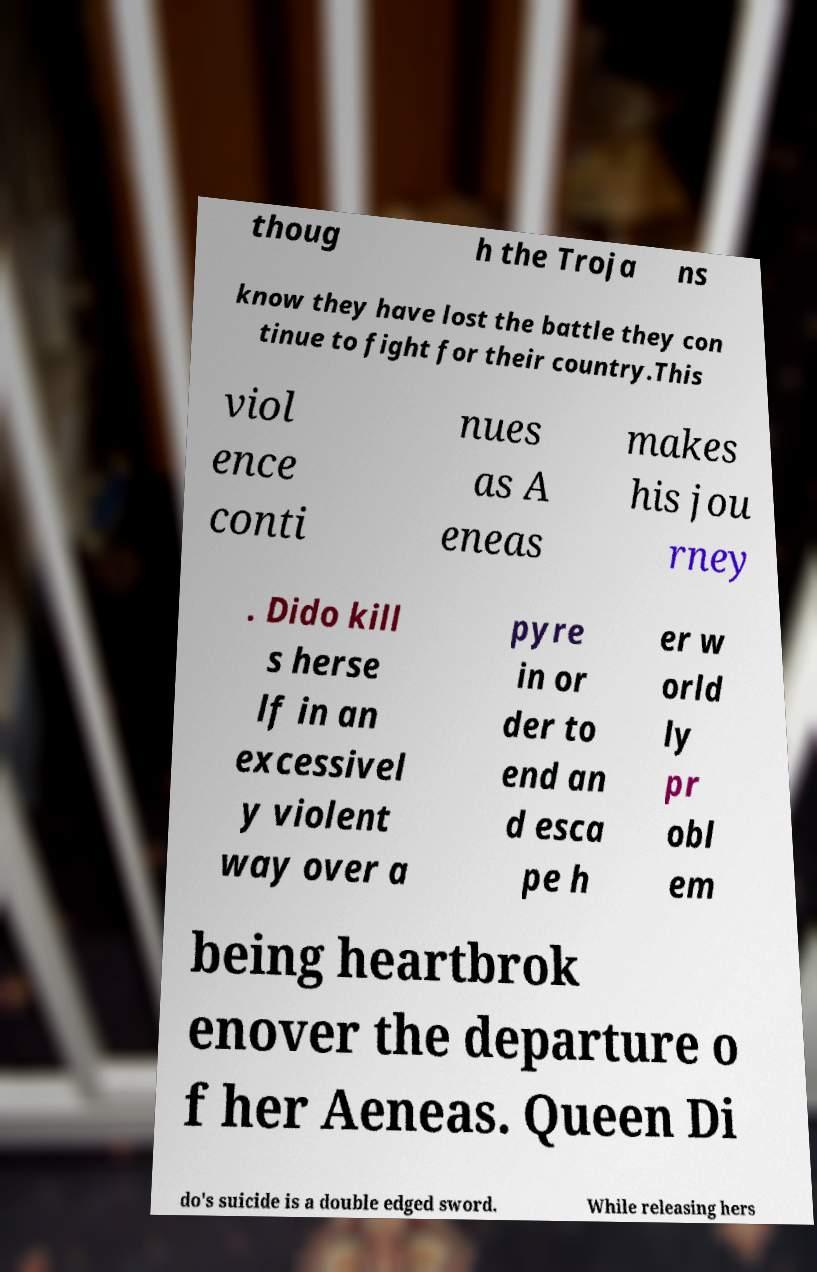Please read and relay the text visible in this image. What does it say? thoug h the Troja ns know they have lost the battle they con tinue to fight for their country.This viol ence conti nues as A eneas makes his jou rney . Dido kill s herse lf in an excessivel y violent way over a pyre in or der to end an d esca pe h er w orld ly pr obl em being heartbrok enover the departure o f her Aeneas. Queen Di do's suicide is a double edged sword. While releasing hers 